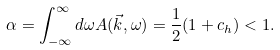Convert formula to latex. <formula><loc_0><loc_0><loc_500><loc_500>\alpha = \int _ { - \infty } ^ { \infty } d \omega A ( \vec { k } , \omega ) = \frac { 1 } { 2 } ( 1 + c _ { h } ) < 1 .</formula> 